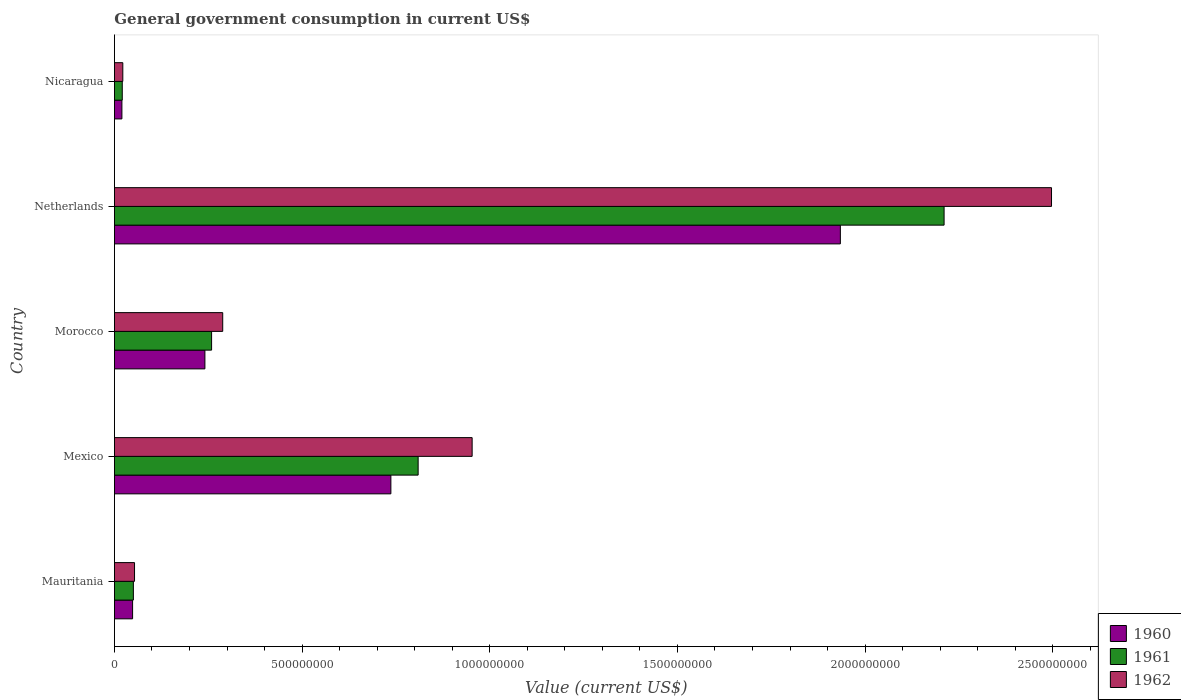How many different coloured bars are there?
Offer a terse response. 3. How many groups of bars are there?
Keep it short and to the point. 5. How many bars are there on the 1st tick from the bottom?
Your response must be concise. 3. What is the label of the 2nd group of bars from the top?
Provide a short and direct response. Netherlands. In how many cases, is the number of bars for a given country not equal to the number of legend labels?
Ensure brevity in your answer.  0. What is the government conusmption in 1960 in Netherlands?
Provide a succinct answer. 1.93e+09. Across all countries, what is the maximum government conusmption in 1962?
Make the answer very short. 2.50e+09. Across all countries, what is the minimum government conusmption in 1962?
Provide a short and direct response. 2.23e+07. In which country was the government conusmption in 1960 maximum?
Provide a succinct answer. Netherlands. In which country was the government conusmption in 1960 minimum?
Offer a terse response. Nicaragua. What is the total government conusmption in 1962 in the graph?
Your answer should be compact. 3.81e+09. What is the difference between the government conusmption in 1960 in Mexico and that in Morocco?
Provide a succinct answer. 4.95e+08. What is the difference between the government conusmption in 1962 in Morocco and the government conusmption in 1961 in Mexico?
Give a very brief answer. -5.21e+08. What is the average government conusmption in 1962 per country?
Your answer should be compact. 7.63e+08. What is the difference between the government conusmption in 1960 and government conusmption in 1961 in Nicaragua?
Your answer should be compact. -9.72e+05. What is the ratio of the government conusmption in 1962 in Mauritania to that in Nicaragua?
Your answer should be compact. 2.4. Is the government conusmption in 1961 in Mauritania less than that in Morocco?
Keep it short and to the point. Yes. Is the difference between the government conusmption in 1960 in Mexico and Morocco greater than the difference between the government conusmption in 1961 in Mexico and Morocco?
Your answer should be compact. No. What is the difference between the highest and the second highest government conusmption in 1962?
Your response must be concise. 1.54e+09. What is the difference between the highest and the lowest government conusmption in 1961?
Ensure brevity in your answer.  2.19e+09. In how many countries, is the government conusmption in 1961 greater than the average government conusmption in 1961 taken over all countries?
Your answer should be very brief. 2. What does the 2nd bar from the bottom in Mauritania represents?
Keep it short and to the point. 1961. Is it the case that in every country, the sum of the government conusmption in 1962 and government conusmption in 1960 is greater than the government conusmption in 1961?
Give a very brief answer. Yes. How many bars are there?
Make the answer very short. 15. Are all the bars in the graph horizontal?
Offer a very short reply. Yes. How many countries are there in the graph?
Provide a short and direct response. 5. What is the difference between two consecutive major ticks on the X-axis?
Ensure brevity in your answer.  5.00e+08. Are the values on the major ticks of X-axis written in scientific E-notation?
Make the answer very short. No. Where does the legend appear in the graph?
Offer a very short reply. Bottom right. What is the title of the graph?
Your response must be concise. General government consumption in current US$. What is the label or title of the X-axis?
Make the answer very short. Value (current US$). What is the label or title of the Y-axis?
Your answer should be very brief. Country. What is the Value (current US$) of 1960 in Mauritania?
Make the answer very short. 4.84e+07. What is the Value (current US$) of 1961 in Mauritania?
Make the answer very short. 5.05e+07. What is the Value (current US$) in 1962 in Mauritania?
Provide a short and direct response. 5.36e+07. What is the Value (current US$) of 1960 in Mexico?
Your response must be concise. 7.37e+08. What is the Value (current US$) of 1961 in Mexico?
Ensure brevity in your answer.  8.09e+08. What is the Value (current US$) of 1962 in Mexico?
Ensure brevity in your answer.  9.53e+08. What is the Value (current US$) of 1960 in Morocco?
Your answer should be very brief. 2.41e+08. What is the Value (current US$) in 1961 in Morocco?
Provide a short and direct response. 2.59e+08. What is the Value (current US$) in 1962 in Morocco?
Ensure brevity in your answer.  2.89e+08. What is the Value (current US$) in 1960 in Netherlands?
Your response must be concise. 1.93e+09. What is the Value (current US$) in 1961 in Netherlands?
Offer a very short reply. 2.21e+09. What is the Value (current US$) in 1962 in Netherlands?
Make the answer very short. 2.50e+09. What is the Value (current US$) in 1960 in Nicaragua?
Give a very brief answer. 1.99e+07. What is the Value (current US$) of 1961 in Nicaragua?
Your answer should be compact. 2.09e+07. What is the Value (current US$) of 1962 in Nicaragua?
Keep it short and to the point. 2.23e+07. Across all countries, what is the maximum Value (current US$) of 1960?
Ensure brevity in your answer.  1.93e+09. Across all countries, what is the maximum Value (current US$) in 1961?
Ensure brevity in your answer.  2.21e+09. Across all countries, what is the maximum Value (current US$) of 1962?
Your answer should be compact. 2.50e+09. Across all countries, what is the minimum Value (current US$) of 1960?
Offer a very short reply. 1.99e+07. Across all countries, what is the minimum Value (current US$) in 1961?
Ensure brevity in your answer.  2.09e+07. Across all countries, what is the minimum Value (current US$) in 1962?
Ensure brevity in your answer.  2.23e+07. What is the total Value (current US$) in 1960 in the graph?
Keep it short and to the point. 2.98e+09. What is the total Value (current US$) in 1961 in the graph?
Provide a succinct answer. 3.35e+09. What is the total Value (current US$) of 1962 in the graph?
Your answer should be compact. 3.81e+09. What is the difference between the Value (current US$) of 1960 in Mauritania and that in Mexico?
Ensure brevity in your answer.  -6.88e+08. What is the difference between the Value (current US$) in 1961 in Mauritania and that in Mexico?
Provide a short and direct response. -7.59e+08. What is the difference between the Value (current US$) in 1962 in Mauritania and that in Mexico?
Offer a terse response. -9.00e+08. What is the difference between the Value (current US$) of 1960 in Mauritania and that in Morocco?
Offer a terse response. -1.93e+08. What is the difference between the Value (current US$) of 1961 in Mauritania and that in Morocco?
Your response must be concise. -2.08e+08. What is the difference between the Value (current US$) in 1962 in Mauritania and that in Morocco?
Provide a succinct answer. -2.35e+08. What is the difference between the Value (current US$) of 1960 in Mauritania and that in Netherlands?
Give a very brief answer. -1.89e+09. What is the difference between the Value (current US$) in 1961 in Mauritania and that in Netherlands?
Give a very brief answer. -2.16e+09. What is the difference between the Value (current US$) in 1962 in Mauritania and that in Netherlands?
Ensure brevity in your answer.  -2.44e+09. What is the difference between the Value (current US$) of 1960 in Mauritania and that in Nicaragua?
Keep it short and to the point. 2.85e+07. What is the difference between the Value (current US$) in 1961 in Mauritania and that in Nicaragua?
Provide a succinct answer. 2.96e+07. What is the difference between the Value (current US$) of 1962 in Mauritania and that in Nicaragua?
Provide a short and direct response. 3.12e+07. What is the difference between the Value (current US$) of 1960 in Mexico and that in Morocco?
Your response must be concise. 4.95e+08. What is the difference between the Value (current US$) of 1961 in Mexico and that in Morocco?
Give a very brief answer. 5.50e+08. What is the difference between the Value (current US$) in 1962 in Mexico and that in Morocco?
Offer a terse response. 6.65e+08. What is the difference between the Value (current US$) in 1960 in Mexico and that in Netherlands?
Provide a short and direct response. -1.20e+09. What is the difference between the Value (current US$) of 1961 in Mexico and that in Netherlands?
Provide a short and direct response. -1.40e+09. What is the difference between the Value (current US$) in 1962 in Mexico and that in Netherlands?
Your answer should be compact. -1.54e+09. What is the difference between the Value (current US$) of 1960 in Mexico and that in Nicaragua?
Your answer should be very brief. 7.17e+08. What is the difference between the Value (current US$) in 1961 in Mexico and that in Nicaragua?
Make the answer very short. 7.88e+08. What is the difference between the Value (current US$) of 1962 in Mexico and that in Nicaragua?
Your answer should be very brief. 9.31e+08. What is the difference between the Value (current US$) in 1960 in Morocco and that in Netherlands?
Provide a succinct answer. -1.69e+09. What is the difference between the Value (current US$) of 1961 in Morocco and that in Netherlands?
Your response must be concise. -1.95e+09. What is the difference between the Value (current US$) in 1962 in Morocco and that in Netherlands?
Provide a succinct answer. -2.21e+09. What is the difference between the Value (current US$) in 1960 in Morocco and that in Nicaragua?
Keep it short and to the point. 2.21e+08. What is the difference between the Value (current US$) in 1961 in Morocco and that in Nicaragua?
Give a very brief answer. 2.38e+08. What is the difference between the Value (current US$) in 1962 in Morocco and that in Nicaragua?
Provide a short and direct response. 2.66e+08. What is the difference between the Value (current US$) of 1960 in Netherlands and that in Nicaragua?
Provide a succinct answer. 1.91e+09. What is the difference between the Value (current US$) in 1961 in Netherlands and that in Nicaragua?
Your response must be concise. 2.19e+09. What is the difference between the Value (current US$) of 1962 in Netherlands and that in Nicaragua?
Your answer should be very brief. 2.47e+09. What is the difference between the Value (current US$) of 1960 in Mauritania and the Value (current US$) of 1961 in Mexico?
Your answer should be compact. -7.61e+08. What is the difference between the Value (current US$) in 1960 in Mauritania and the Value (current US$) in 1962 in Mexico?
Ensure brevity in your answer.  -9.05e+08. What is the difference between the Value (current US$) of 1961 in Mauritania and the Value (current US$) of 1962 in Mexico?
Give a very brief answer. -9.03e+08. What is the difference between the Value (current US$) in 1960 in Mauritania and the Value (current US$) in 1961 in Morocco?
Provide a succinct answer. -2.10e+08. What is the difference between the Value (current US$) in 1960 in Mauritania and the Value (current US$) in 1962 in Morocco?
Offer a very short reply. -2.40e+08. What is the difference between the Value (current US$) in 1961 in Mauritania and the Value (current US$) in 1962 in Morocco?
Keep it short and to the point. -2.38e+08. What is the difference between the Value (current US$) in 1960 in Mauritania and the Value (current US$) in 1961 in Netherlands?
Provide a succinct answer. -2.16e+09. What is the difference between the Value (current US$) in 1960 in Mauritania and the Value (current US$) in 1962 in Netherlands?
Make the answer very short. -2.45e+09. What is the difference between the Value (current US$) of 1961 in Mauritania and the Value (current US$) of 1962 in Netherlands?
Ensure brevity in your answer.  -2.45e+09. What is the difference between the Value (current US$) in 1960 in Mauritania and the Value (current US$) in 1961 in Nicaragua?
Provide a short and direct response. 2.75e+07. What is the difference between the Value (current US$) in 1960 in Mauritania and the Value (current US$) in 1962 in Nicaragua?
Provide a succinct answer. 2.61e+07. What is the difference between the Value (current US$) of 1961 in Mauritania and the Value (current US$) of 1962 in Nicaragua?
Offer a terse response. 2.81e+07. What is the difference between the Value (current US$) in 1960 in Mexico and the Value (current US$) in 1961 in Morocco?
Make the answer very short. 4.78e+08. What is the difference between the Value (current US$) of 1960 in Mexico and the Value (current US$) of 1962 in Morocco?
Ensure brevity in your answer.  4.48e+08. What is the difference between the Value (current US$) in 1961 in Mexico and the Value (current US$) in 1962 in Morocco?
Offer a very short reply. 5.21e+08. What is the difference between the Value (current US$) in 1960 in Mexico and the Value (current US$) in 1961 in Netherlands?
Provide a short and direct response. -1.47e+09. What is the difference between the Value (current US$) of 1960 in Mexico and the Value (current US$) of 1962 in Netherlands?
Give a very brief answer. -1.76e+09. What is the difference between the Value (current US$) of 1961 in Mexico and the Value (current US$) of 1962 in Netherlands?
Offer a terse response. -1.69e+09. What is the difference between the Value (current US$) in 1960 in Mexico and the Value (current US$) in 1961 in Nicaragua?
Your answer should be very brief. 7.16e+08. What is the difference between the Value (current US$) of 1960 in Mexico and the Value (current US$) of 1962 in Nicaragua?
Offer a terse response. 7.14e+08. What is the difference between the Value (current US$) of 1961 in Mexico and the Value (current US$) of 1962 in Nicaragua?
Make the answer very short. 7.87e+08. What is the difference between the Value (current US$) of 1960 in Morocco and the Value (current US$) of 1961 in Netherlands?
Provide a short and direct response. -1.97e+09. What is the difference between the Value (current US$) of 1960 in Morocco and the Value (current US$) of 1962 in Netherlands?
Ensure brevity in your answer.  -2.26e+09. What is the difference between the Value (current US$) in 1961 in Morocco and the Value (current US$) in 1962 in Netherlands?
Your answer should be very brief. -2.24e+09. What is the difference between the Value (current US$) in 1960 in Morocco and the Value (current US$) in 1961 in Nicaragua?
Make the answer very short. 2.20e+08. What is the difference between the Value (current US$) in 1960 in Morocco and the Value (current US$) in 1962 in Nicaragua?
Provide a succinct answer. 2.19e+08. What is the difference between the Value (current US$) in 1961 in Morocco and the Value (current US$) in 1962 in Nicaragua?
Provide a short and direct response. 2.37e+08. What is the difference between the Value (current US$) in 1960 in Netherlands and the Value (current US$) in 1961 in Nicaragua?
Make the answer very short. 1.91e+09. What is the difference between the Value (current US$) in 1960 in Netherlands and the Value (current US$) in 1962 in Nicaragua?
Give a very brief answer. 1.91e+09. What is the difference between the Value (current US$) in 1961 in Netherlands and the Value (current US$) in 1962 in Nicaragua?
Make the answer very short. 2.19e+09. What is the average Value (current US$) in 1960 per country?
Your answer should be very brief. 5.96e+08. What is the average Value (current US$) in 1961 per country?
Offer a terse response. 6.70e+08. What is the average Value (current US$) of 1962 per country?
Offer a very short reply. 7.63e+08. What is the difference between the Value (current US$) in 1960 and Value (current US$) in 1961 in Mauritania?
Make the answer very short. -2.06e+06. What is the difference between the Value (current US$) in 1960 and Value (current US$) in 1962 in Mauritania?
Give a very brief answer. -5.15e+06. What is the difference between the Value (current US$) in 1961 and Value (current US$) in 1962 in Mauritania?
Your answer should be compact. -3.09e+06. What is the difference between the Value (current US$) of 1960 and Value (current US$) of 1961 in Mexico?
Provide a short and direct response. -7.27e+07. What is the difference between the Value (current US$) of 1960 and Value (current US$) of 1962 in Mexico?
Your answer should be very brief. -2.17e+08. What is the difference between the Value (current US$) of 1961 and Value (current US$) of 1962 in Mexico?
Give a very brief answer. -1.44e+08. What is the difference between the Value (current US$) in 1960 and Value (current US$) in 1961 in Morocco?
Your response must be concise. -1.78e+07. What is the difference between the Value (current US$) of 1960 and Value (current US$) of 1962 in Morocco?
Offer a very short reply. -4.74e+07. What is the difference between the Value (current US$) of 1961 and Value (current US$) of 1962 in Morocco?
Offer a very short reply. -2.96e+07. What is the difference between the Value (current US$) in 1960 and Value (current US$) in 1961 in Netherlands?
Provide a succinct answer. -2.76e+08. What is the difference between the Value (current US$) in 1960 and Value (current US$) in 1962 in Netherlands?
Your answer should be very brief. -5.63e+08. What is the difference between the Value (current US$) in 1961 and Value (current US$) in 1962 in Netherlands?
Provide a short and direct response. -2.86e+08. What is the difference between the Value (current US$) of 1960 and Value (current US$) of 1961 in Nicaragua?
Ensure brevity in your answer.  -9.72e+05. What is the difference between the Value (current US$) of 1960 and Value (current US$) of 1962 in Nicaragua?
Give a very brief answer. -2.43e+06. What is the difference between the Value (current US$) of 1961 and Value (current US$) of 1962 in Nicaragua?
Your answer should be compact. -1.46e+06. What is the ratio of the Value (current US$) in 1960 in Mauritania to that in Mexico?
Provide a short and direct response. 0.07. What is the ratio of the Value (current US$) of 1961 in Mauritania to that in Mexico?
Offer a very short reply. 0.06. What is the ratio of the Value (current US$) of 1962 in Mauritania to that in Mexico?
Your answer should be compact. 0.06. What is the ratio of the Value (current US$) of 1960 in Mauritania to that in Morocco?
Your answer should be compact. 0.2. What is the ratio of the Value (current US$) of 1961 in Mauritania to that in Morocco?
Give a very brief answer. 0.2. What is the ratio of the Value (current US$) of 1962 in Mauritania to that in Morocco?
Your response must be concise. 0.19. What is the ratio of the Value (current US$) in 1960 in Mauritania to that in Netherlands?
Your answer should be very brief. 0.03. What is the ratio of the Value (current US$) of 1961 in Mauritania to that in Netherlands?
Offer a very short reply. 0.02. What is the ratio of the Value (current US$) of 1962 in Mauritania to that in Netherlands?
Give a very brief answer. 0.02. What is the ratio of the Value (current US$) in 1960 in Mauritania to that in Nicaragua?
Your response must be concise. 2.43. What is the ratio of the Value (current US$) of 1961 in Mauritania to that in Nicaragua?
Offer a terse response. 2.42. What is the ratio of the Value (current US$) of 1962 in Mauritania to that in Nicaragua?
Your answer should be very brief. 2.4. What is the ratio of the Value (current US$) of 1960 in Mexico to that in Morocco?
Keep it short and to the point. 3.06. What is the ratio of the Value (current US$) in 1961 in Mexico to that in Morocco?
Your answer should be compact. 3.13. What is the ratio of the Value (current US$) of 1962 in Mexico to that in Morocco?
Offer a terse response. 3.3. What is the ratio of the Value (current US$) of 1960 in Mexico to that in Netherlands?
Give a very brief answer. 0.38. What is the ratio of the Value (current US$) of 1961 in Mexico to that in Netherlands?
Give a very brief answer. 0.37. What is the ratio of the Value (current US$) of 1962 in Mexico to that in Netherlands?
Your answer should be very brief. 0.38. What is the ratio of the Value (current US$) of 1960 in Mexico to that in Nicaragua?
Keep it short and to the point. 36.98. What is the ratio of the Value (current US$) of 1961 in Mexico to that in Nicaragua?
Give a very brief answer. 38.74. What is the ratio of the Value (current US$) in 1962 in Mexico to that in Nicaragua?
Provide a succinct answer. 42.65. What is the ratio of the Value (current US$) of 1960 in Morocco to that in Netherlands?
Provide a succinct answer. 0.12. What is the ratio of the Value (current US$) in 1961 in Morocco to that in Netherlands?
Your response must be concise. 0.12. What is the ratio of the Value (current US$) of 1962 in Morocco to that in Netherlands?
Provide a short and direct response. 0.12. What is the ratio of the Value (current US$) in 1960 in Morocco to that in Nicaragua?
Keep it short and to the point. 12.1. What is the ratio of the Value (current US$) in 1961 in Morocco to that in Nicaragua?
Your answer should be compact. 12.39. What is the ratio of the Value (current US$) in 1962 in Morocco to that in Nicaragua?
Provide a succinct answer. 12.91. What is the ratio of the Value (current US$) in 1960 in Netherlands to that in Nicaragua?
Make the answer very short. 97.11. What is the ratio of the Value (current US$) in 1961 in Netherlands to that in Nicaragua?
Keep it short and to the point. 105.82. What is the ratio of the Value (current US$) of 1962 in Netherlands to that in Nicaragua?
Ensure brevity in your answer.  111.73. What is the difference between the highest and the second highest Value (current US$) in 1960?
Keep it short and to the point. 1.20e+09. What is the difference between the highest and the second highest Value (current US$) in 1961?
Your answer should be compact. 1.40e+09. What is the difference between the highest and the second highest Value (current US$) of 1962?
Your response must be concise. 1.54e+09. What is the difference between the highest and the lowest Value (current US$) of 1960?
Keep it short and to the point. 1.91e+09. What is the difference between the highest and the lowest Value (current US$) of 1961?
Provide a succinct answer. 2.19e+09. What is the difference between the highest and the lowest Value (current US$) in 1962?
Your answer should be compact. 2.47e+09. 